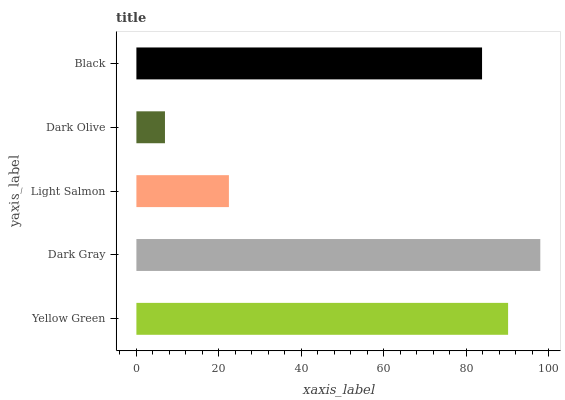Is Dark Olive the minimum?
Answer yes or no. Yes. Is Dark Gray the maximum?
Answer yes or no. Yes. Is Light Salmon the minimum?
Answer yes or no. No. Is Light Salmon the maximum?
Answer yes or no. No. Is Dark Gray greater than Light Salmon?
Answer yes or no. Yes. Is Light Salmon less than Dark Gray?
Answer yes or no. Yes. Is Light Salmon greater than Dark Gray?
Answer yes or no. No. Is Dark Gray less than Light Salmon?
Answer yes or no. No. Is Black the high median?
Answer yes or no. Yes. Is Black the low median?
Answer yes or no. Yes. Is Light Salmon the high median?
Answer yes or no. No. Is Light Salmon the low median?
Answer yes or no. No. 